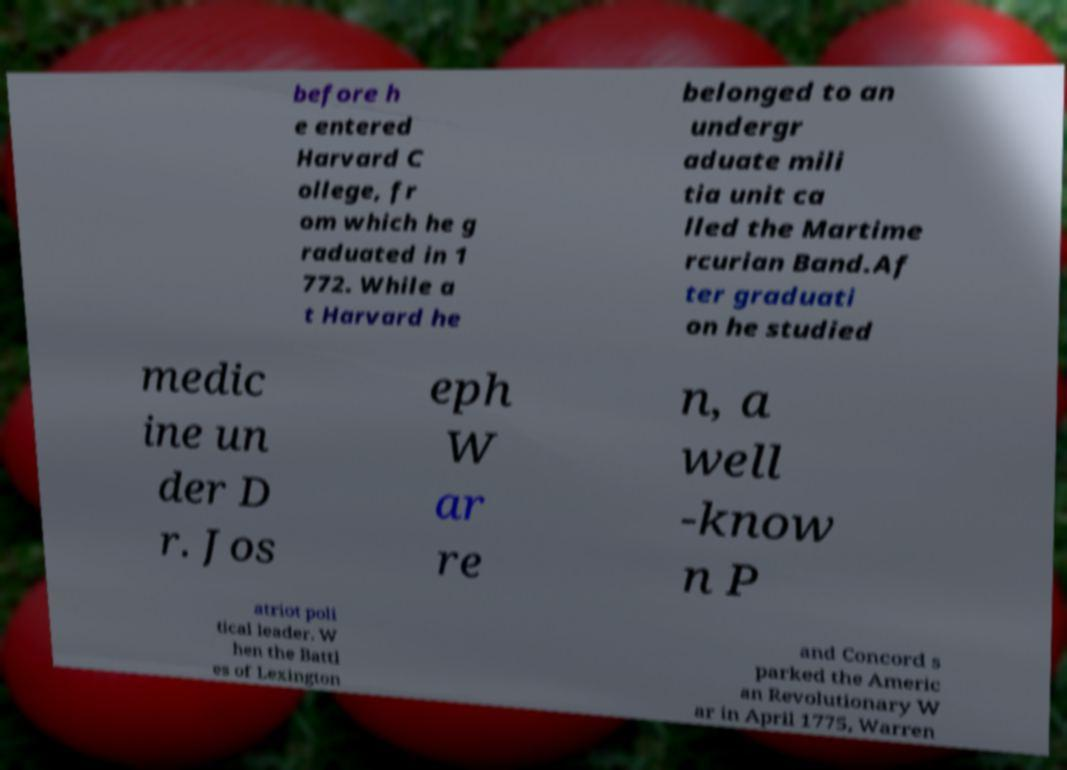Can you read and provide the text displayed in the image?This photo seems to have some interesting text. Can you extract and type it out for me? before h e entered Harvard C ollege, fr om which he g raduated in 1 772. While a t Harvard he belonged to an undergr aduate mili tia unit ca lled the Martime rcurian Band.Af ter graduati on he studied medic ine un der D r. Jos eph W ar re n, a well -know n P atriot poli tical leader. W hen the Battl es of Lexington and Concord s parked the Americ an Revolutionary W ar in April 1775, Warren 